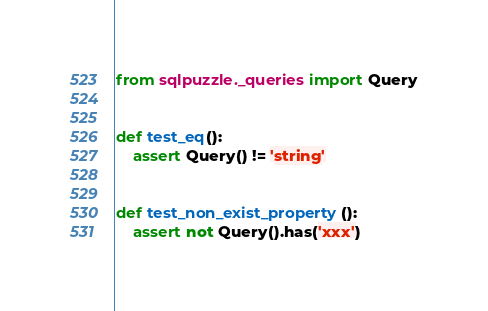Convert code to text. <code><loc_0><loc_0><loc_500><loc_500><_Python_>from sqlpuzzle._queries import Query


def test_eq():
    assert Query() != 'string'


def test_non_exist_property():
    assert not Query().has('xxx')
</code> 